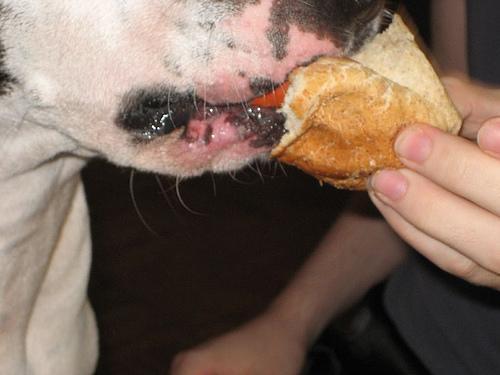How many dogs are in the picture?
Give a very brief answer. 1. How many people are in the photo?
Give a very brief answer. 1. 